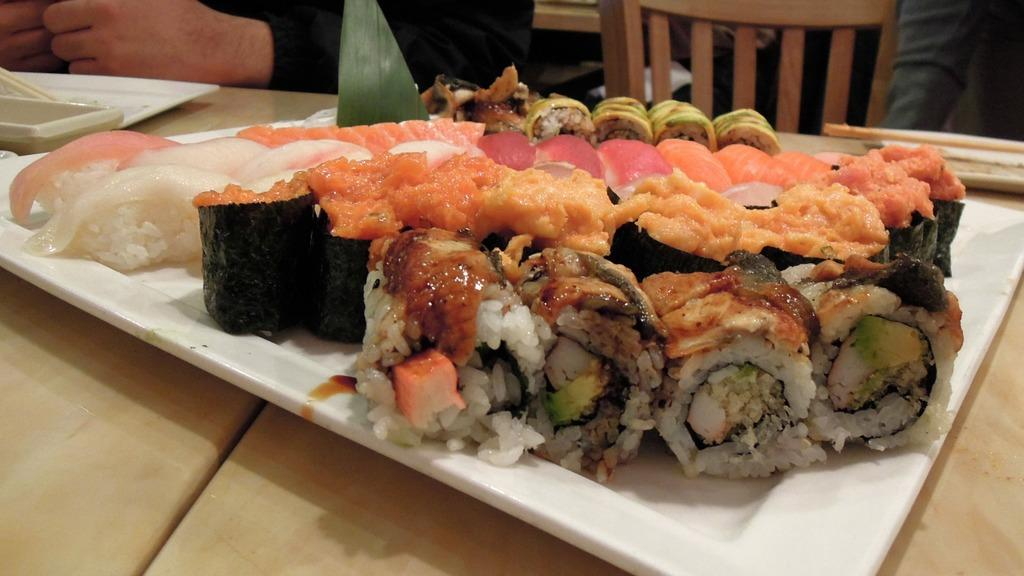What is on the plates that are visible in the image? There are plates with food items in the image. Where are the plates located? The plates are on a table. Can you describe the setting in the image? There is a person sitting on a chair in the background of the image, and it may have been taken in a hotel. What type of drug can be seen in the jar on the table in the image? There is no jar or drug present in the image; it only features plates with food items on a table. 